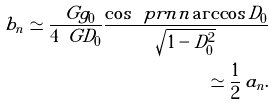Convert formula to latex. <formula><loc_0><loc_0><loc_500><loc_500>b _ { n } \simeq \frac { \ G g _ { 0 } } { 4 \ G D _ { 0 } } \frac { \cos \ p r n { n \arccos { D _ { 0 } } } } { \sqrt { 1 - D _ { 0 } ^ { 2 } } } \\ \simeq \frac { 1 } { 2 } \, a _ { n } .</formula> 